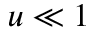<formula> <loc_0><loc_0><loc_500><loc_500>u \ll 1</formula> 